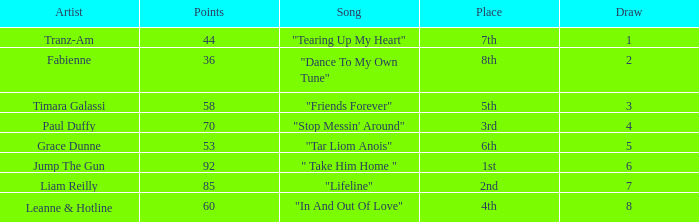What's the song of artist liam reilly? "Lifeline". 